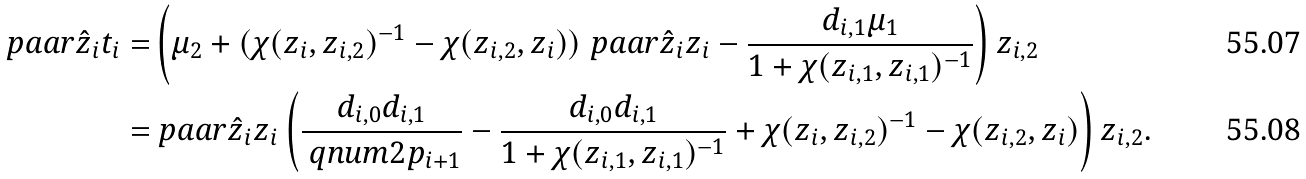Convert formula to latex. <formula><loc_0><loc_0><loc_500><loc_500>\ p a a r { \hat { z } _ { i } } { t _ { i } } = & \left ( \mu _ { 2 } + ( \chi ( z _ { i } , z _ { i , 2 } ) ^ { - 1 } - \chi ( z _ { i , 2 } , z _ { i } ) ) \ p a a r { \hat { z } _ { i } } { z _ { i } } - \frac { d _ { i , 1 } \mu _ { 1 } } { 1 + \chi ( z _ { i , 1 } , z _ { i , 1 } ) ^ { - 1 } } \right ) z _ { i , 2 } \\ = & \ p a a r { \hat { z } _ { i } } { z _ { i } } \left ( \frac { d _ { i , 0 } d _ { i , 1 } } { \ q n u m { 2 } { p _ { i + 1 } } } - \frac { d _ { i , 0 } d _ { i , 1 } } { 1 + \chi ( z _ { i , 1 } , z _ { i , 1 } ) ^ { - 1 } } + \chi ( z _ { i } , z _ { i , 2 } ) ^ { - 1 } - \chi ( z _ { i , 2 } , z _ { i } ) \right ) z _ { i , 2 } .</formula> 